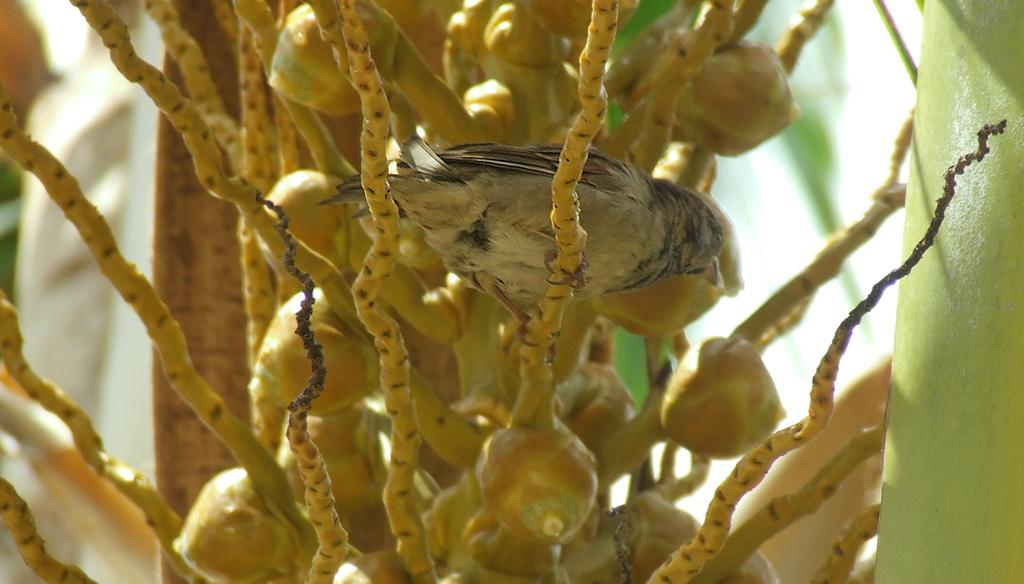What type of tree is in the picture? There is a coconut tree in the picture. Are there any coconuts on the tree? Yes, the coconut tree has small coconuts on it. Is there any wildlife present in the image? Yes, there is a bird standing on the coconut tree. Can you see the hand of the person who gave approval for the bird to stand on the coconut tree? There is no hand or person visible in the image, nor is there any indication of approval for the bird's presence on the tree. 